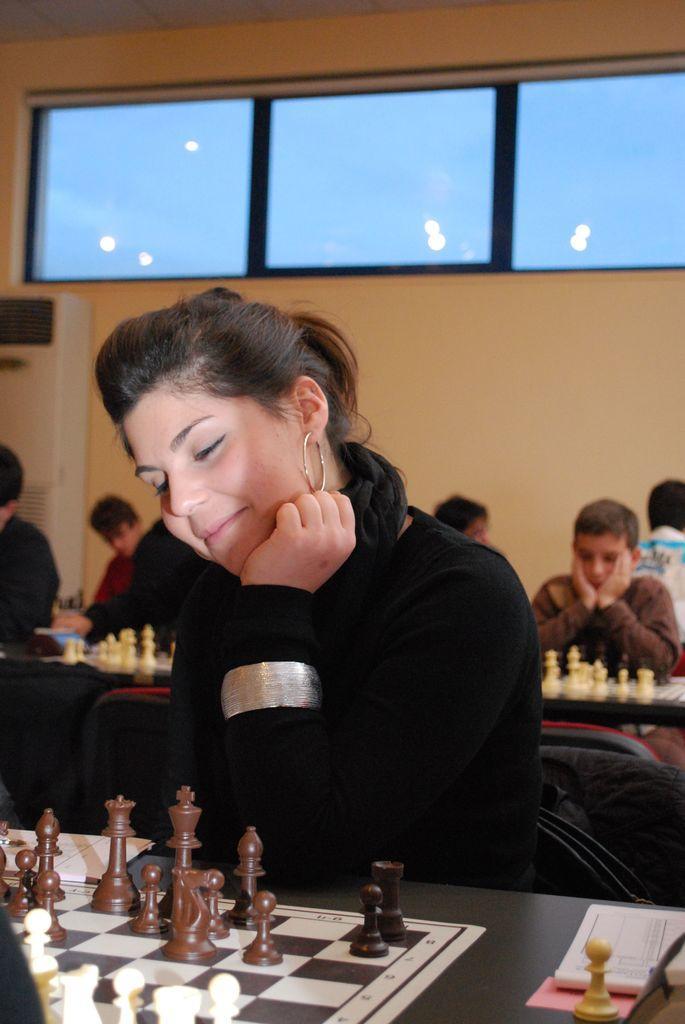Can you describe this image briefly? In this image we can see a woman sitting on a chair and she is smiling. This is a table where a chess board is kept on it. In the background we can see a few people who are playing a chess. Here we can see a glass window. 